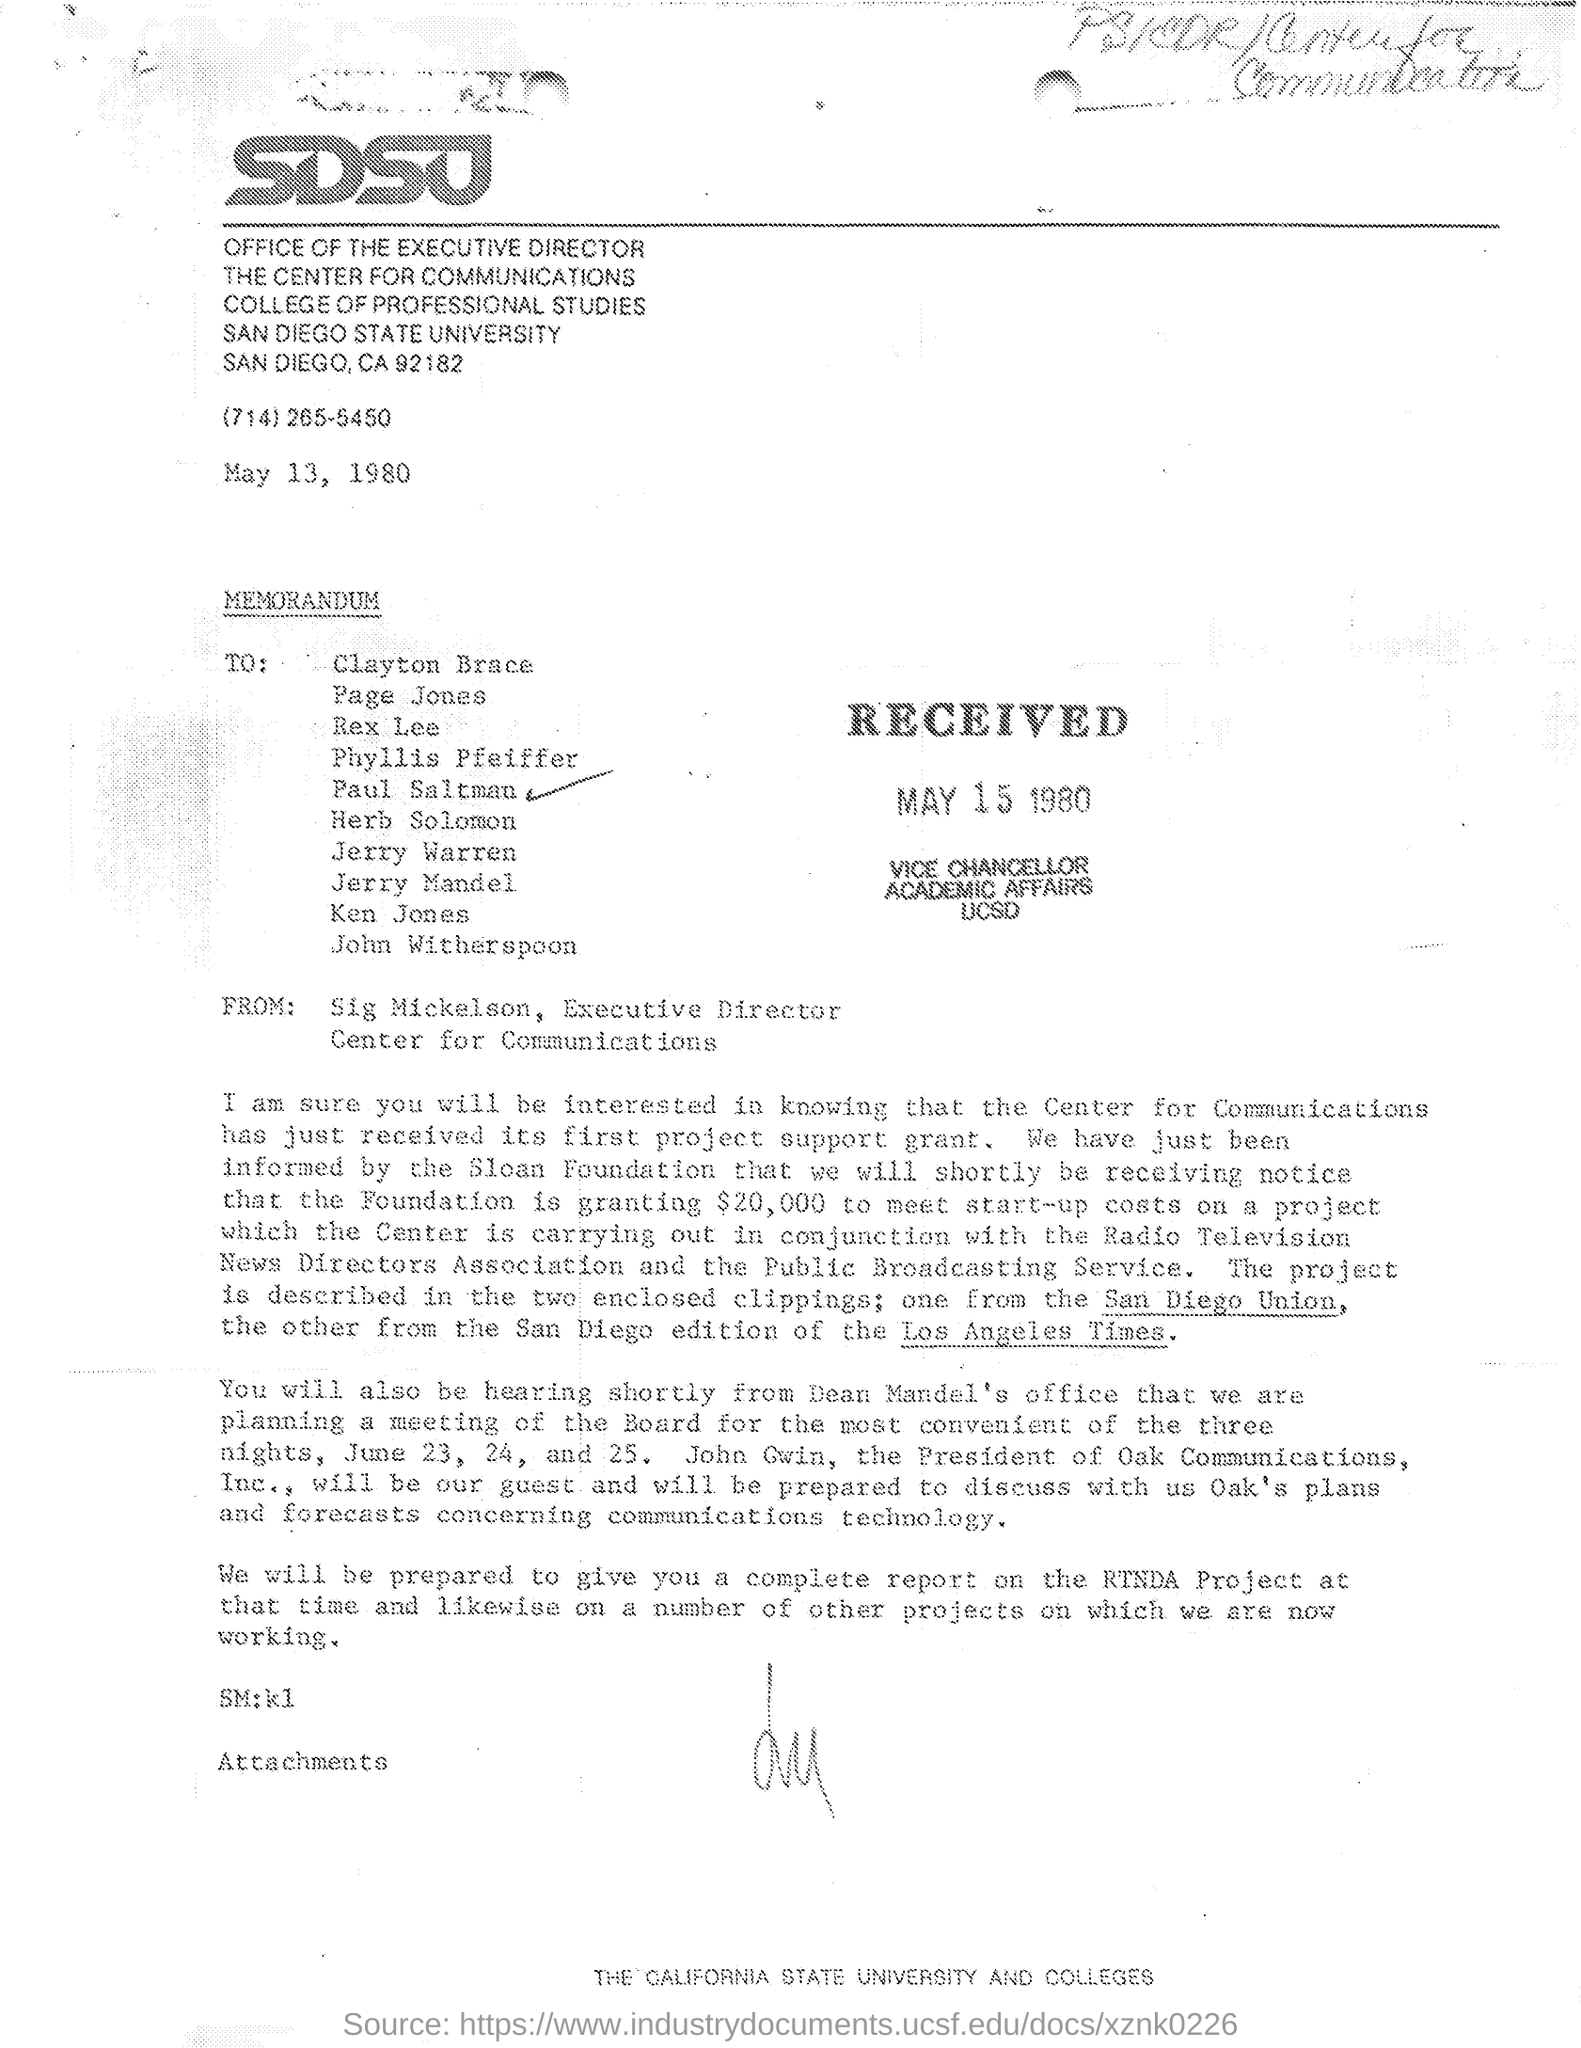What is the received date of this memorandum?
Provide a short and direct response. May 15 1980. Who is the sender of this memorandum?
Keep it short and to the point. Sig Mickelson. 